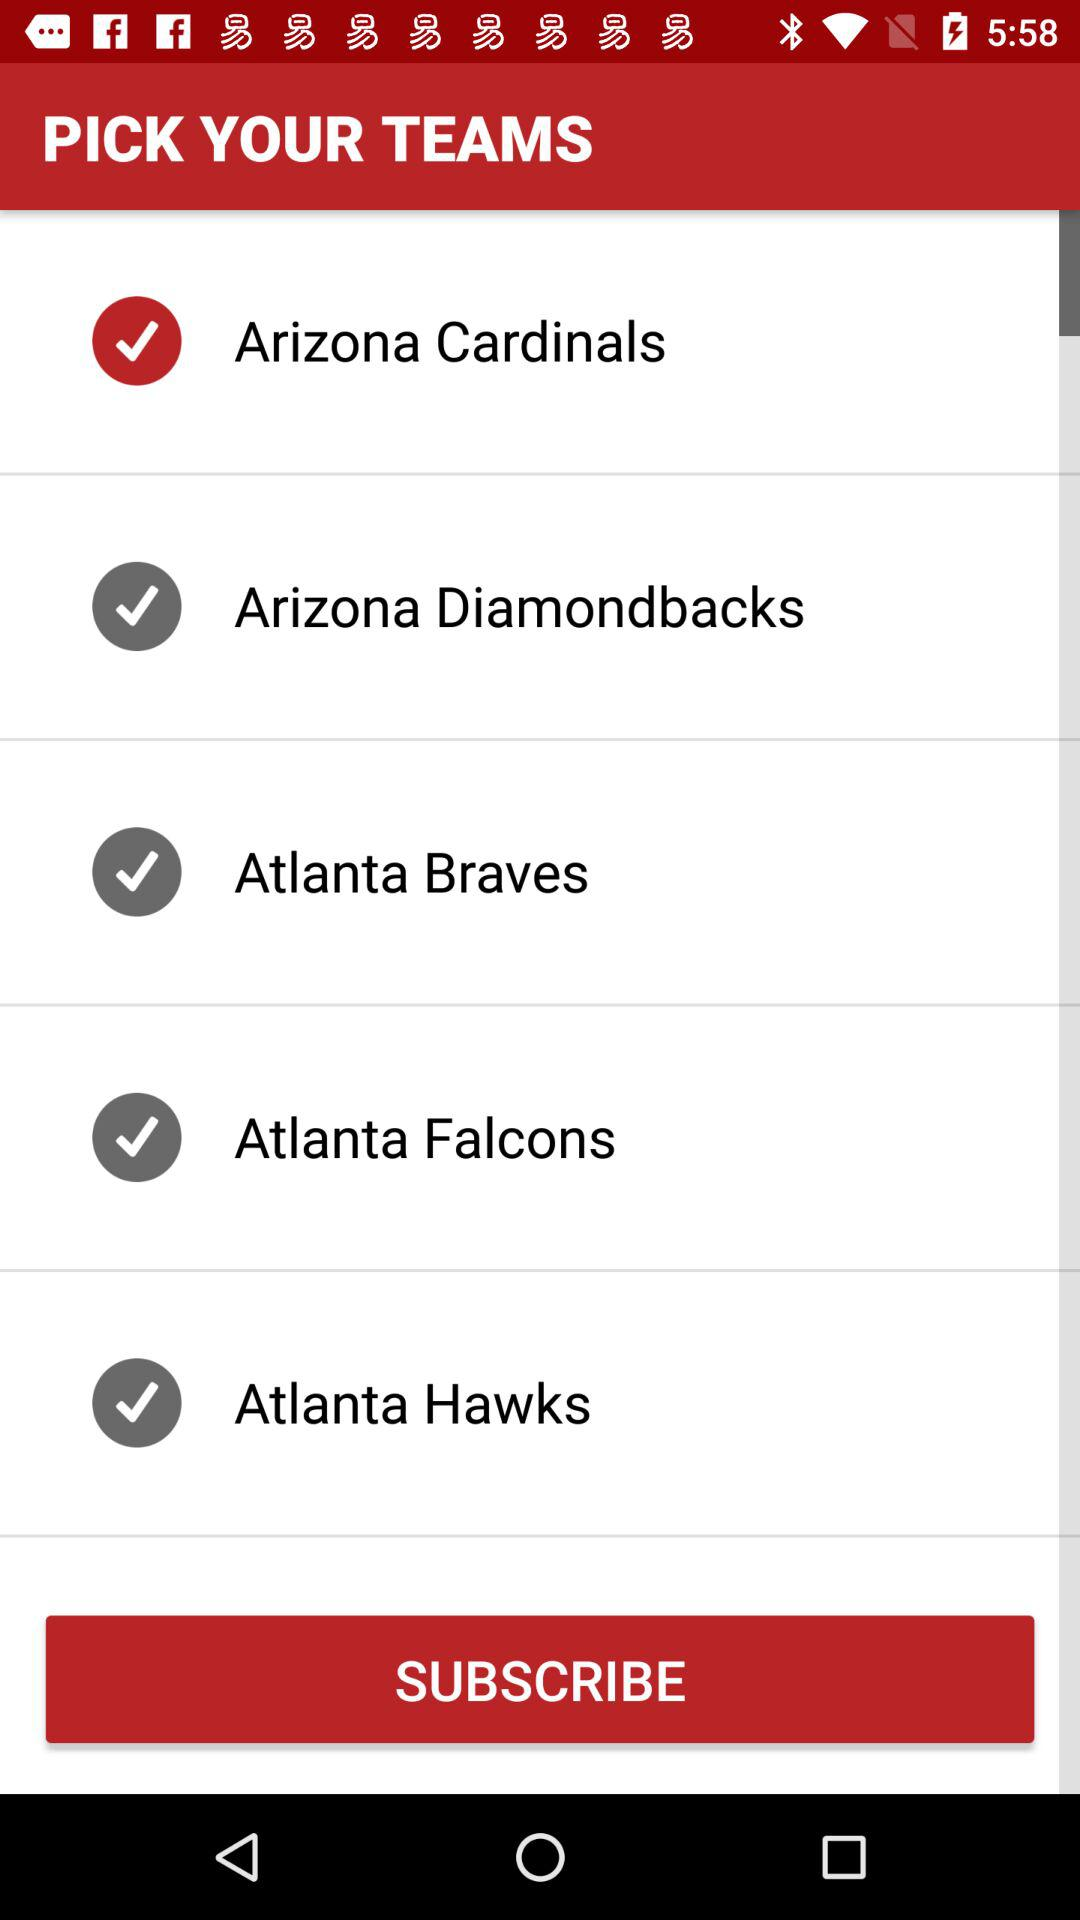What teams are available on the list? The teams are Arizona Cardinals, Arizona Diamondbacks, Atlanta Braves, Atlanta Falcons and Atlanta Hawks. 